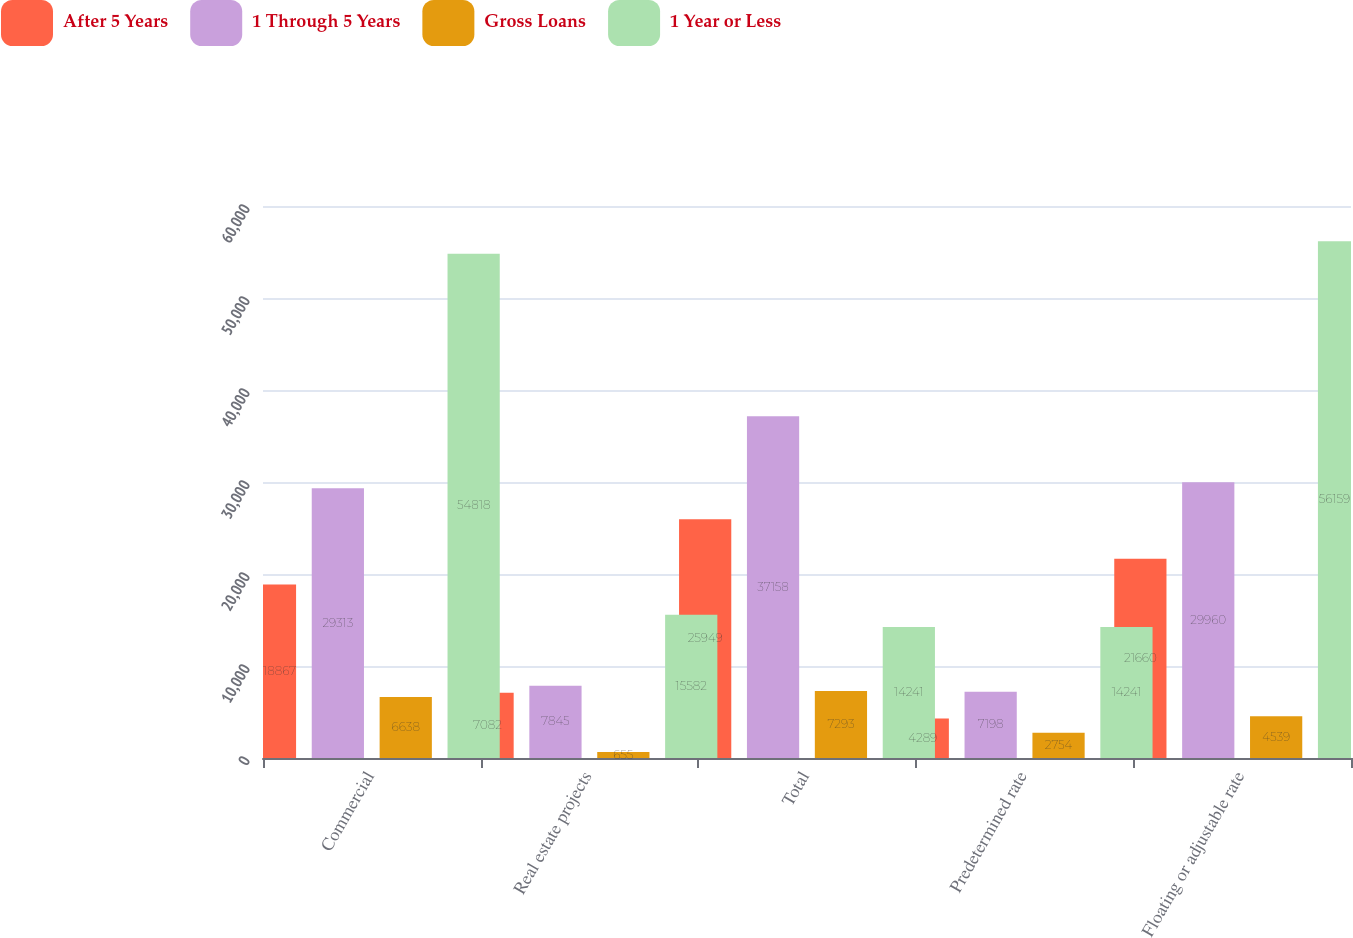Convert chart to OTSL. <chart><loc_0><loc_0><loc_500><loc_500><stacked_bar_chart><ecel><fcel>Commercial<fcel>Real estate projects<fcel>Total<fcel>Predetermined rate<fcel>Floating or adjustable rate<nl><fcel>After 5 Years<fcel>18867<fcel>7082<fcel>25949<fcel>4289<fcel>21660<nl><fcel>1 Through 5 Years<fcel>29313<fcel>7845<fcel>37158<fcel>7198<fcel>29960<nl><fcel>Gross Loans<fcel>6638<fcel>655<fcel>7293<fcel>2754<fcel>4539<nl><fcel>1 Year or Less<fcel>54818<fcel>15582<fcel>14241<fcel>14241<fcel>56159<nl></chart> 